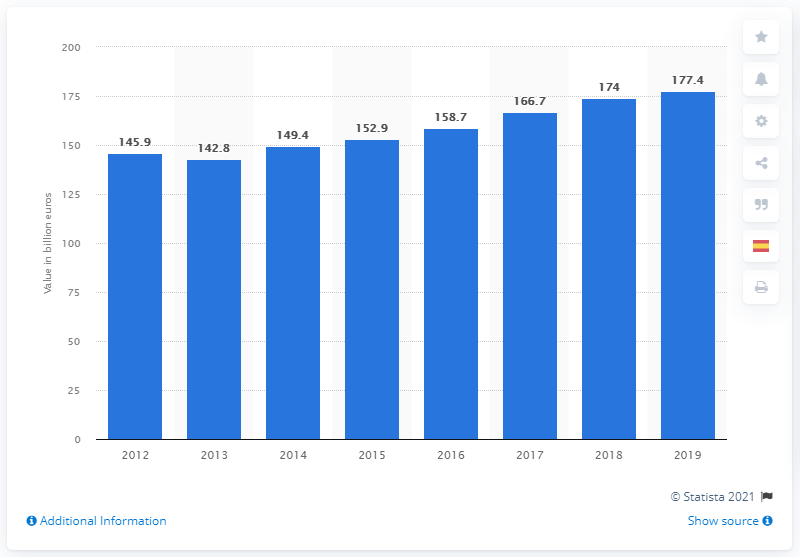How does Spain's GDP in 2019 compare to previous years? The GDP of Spain in 2019 shows an increase compared to previous years. It is the highest on the chart at €1.774 trillion, indicating a positive economic growth trend over the past several years. 